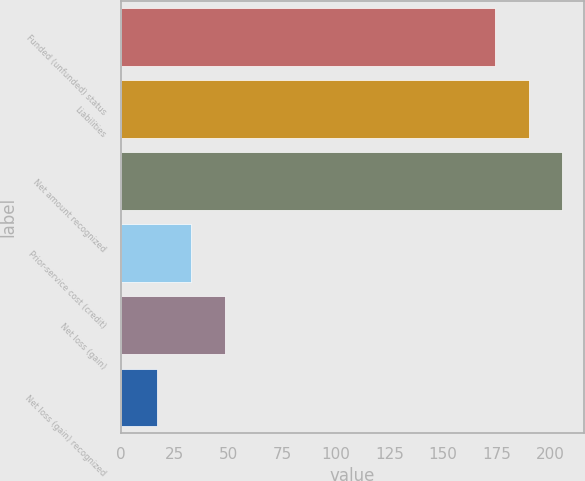Convert chart. <chart><loc_0><loc_0><loc_500><loc_500><bar_chart><fcel>Funded (unfunded) status<fcel>Liabilities<fcel>Net amount recognized<fcel>Prior-service cost (credit)<fcel>Net loss (gain)<fcel>Net loss (gain) recognized<nl><fcel>174<fcel>189.7<fcel>205.4<fcel>32.7<fcel>48.4<fcel>17<nl></chart> 